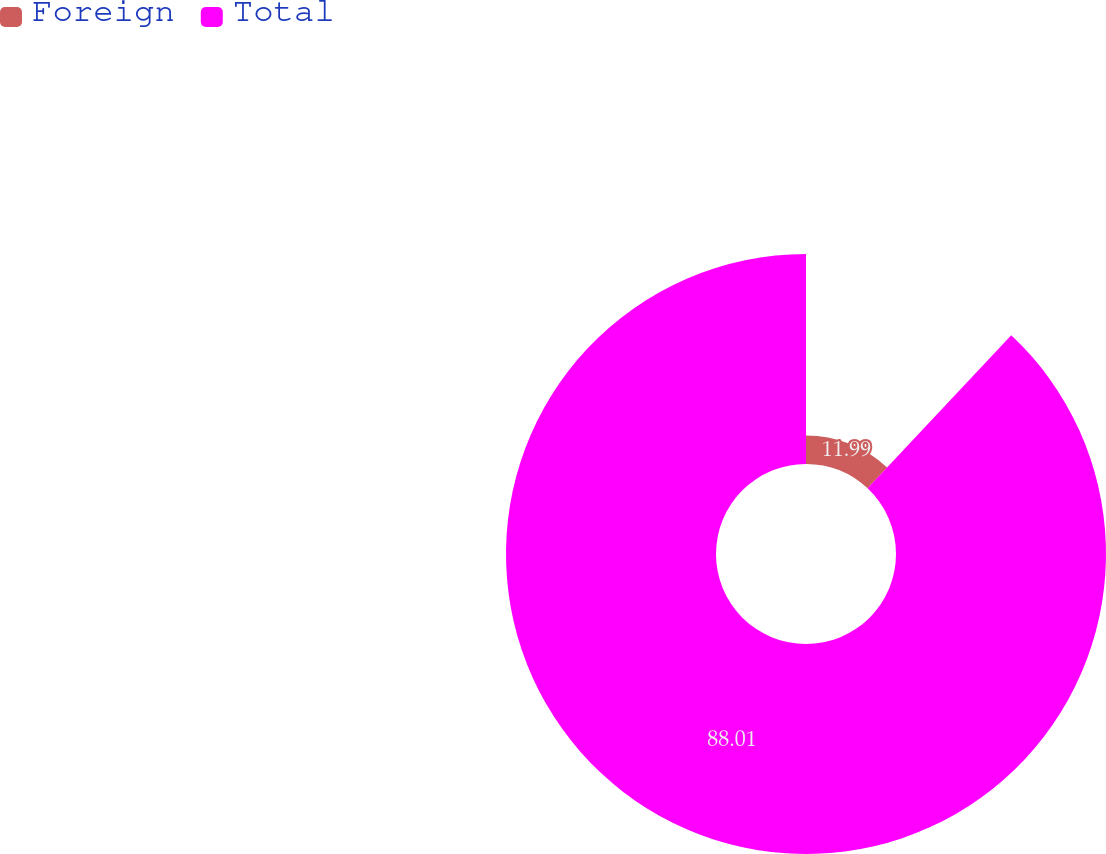<chart> <loc_0><loc_0><loc_500><loc_500><pie_chart><fcel>Foreign<fcel>Total<nl><fcel>11.99%<fcel>88.01%<nl></chart> 